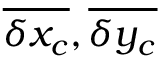Convert formula to latex. <formula><loc_0><loc_0><loc_500><loc_500>\overline { { \delta { x _ { c } } } } , \overline { { \delta { y _ { c } } } }</formula> 